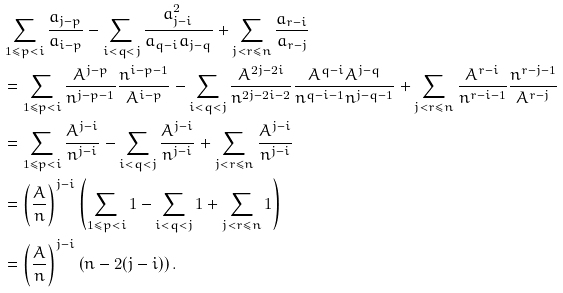Convert formula to latex. <formula><loc_0><loc_0><loc_500><loc_500>& \sum _ { 1 \leq p < i } \frac { a _ { j - p } } { a _ { i - p } } - \sum _ { i < q < j } \frac { a _ { j - i } ^ { 2 } } { a _ { q - i } a _ { j - q } } + \sum _ { j < r \leq n } \frac { a _ { r - i } } { a _ { r - j } } \\ & = \sum _ { 1 \leq p < i } \frac { A ^ { j - p } } { n ^ { j - p - 1 } } \frac { n ^ { i - p - 1 } } { A ^ { i - p } } - \sum _ { i < q < j } \frac { A ^ { 2 j - 2 i } } { n ^ { 2 j - 2 i - 2 } } \frac { A ^ { q - i } A ^ { j - q } } { n ^ { q - i - 1 } n ^ { j - q - 1 } } + \sum _ { j < r \leq n } \frac { A ^ { r - i } } { n ^ { r - i - 1 } } \frac { n ^ { r - j - 1 } } { A ^ { r - j } } \\ & = \sum _ { 1 \leq p < i } \frac { A ^ { j - i } } { n ^ { j - i } } - \sum _ { i < q < j } \frac { A ^ { j - i } } { n ^ { j - i } } + \sum _ { j < r \leq n } \frac { A ^ { j - i } } { n ^ { j - i } } \\ & = \left ( \frac { A } { n } \right ) ^ { j - i } \left ( \sum _ { 1 \leq p < i } 1 - \sum _ { i < q < j } 1 + \sum _ { j < r \leq n } 1 \right ) \\ & = \left ( \frac { A } { n } \right ) ^ { j - i } \left ( n - 2 ( j - i ) \right ) .</formula> 